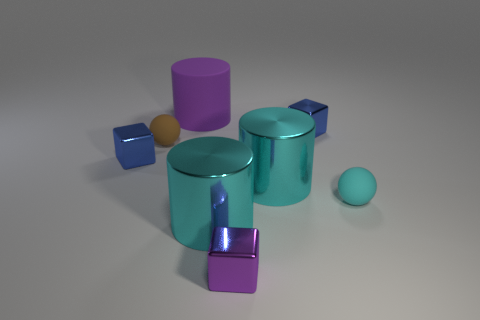Subtract all blue blocks. How many were subtracted if there are1blue blocks left? 1 Subtract all spheres. How many objects are left? 6 Subtract 1 blocks. How many blocks are left? 2 Subtract all red spheres. Subtract all yellow cylinders. How many spheres are left? 2 Subtract all red cylinders. How many gray balls are left? 0 Subtract all large shiny cylinders. Subtract all cyan matte balls. How many objects are left? 5 Add 7 big purple objects. How many big purple objects are left? 8 Add 2 rubber cylinders. How many rubber cylinders exist? 3 Add 2 tiny cyan things. How many objects exist? 10 Subtract all cyan cylinders. How many cylinders are left? 1 